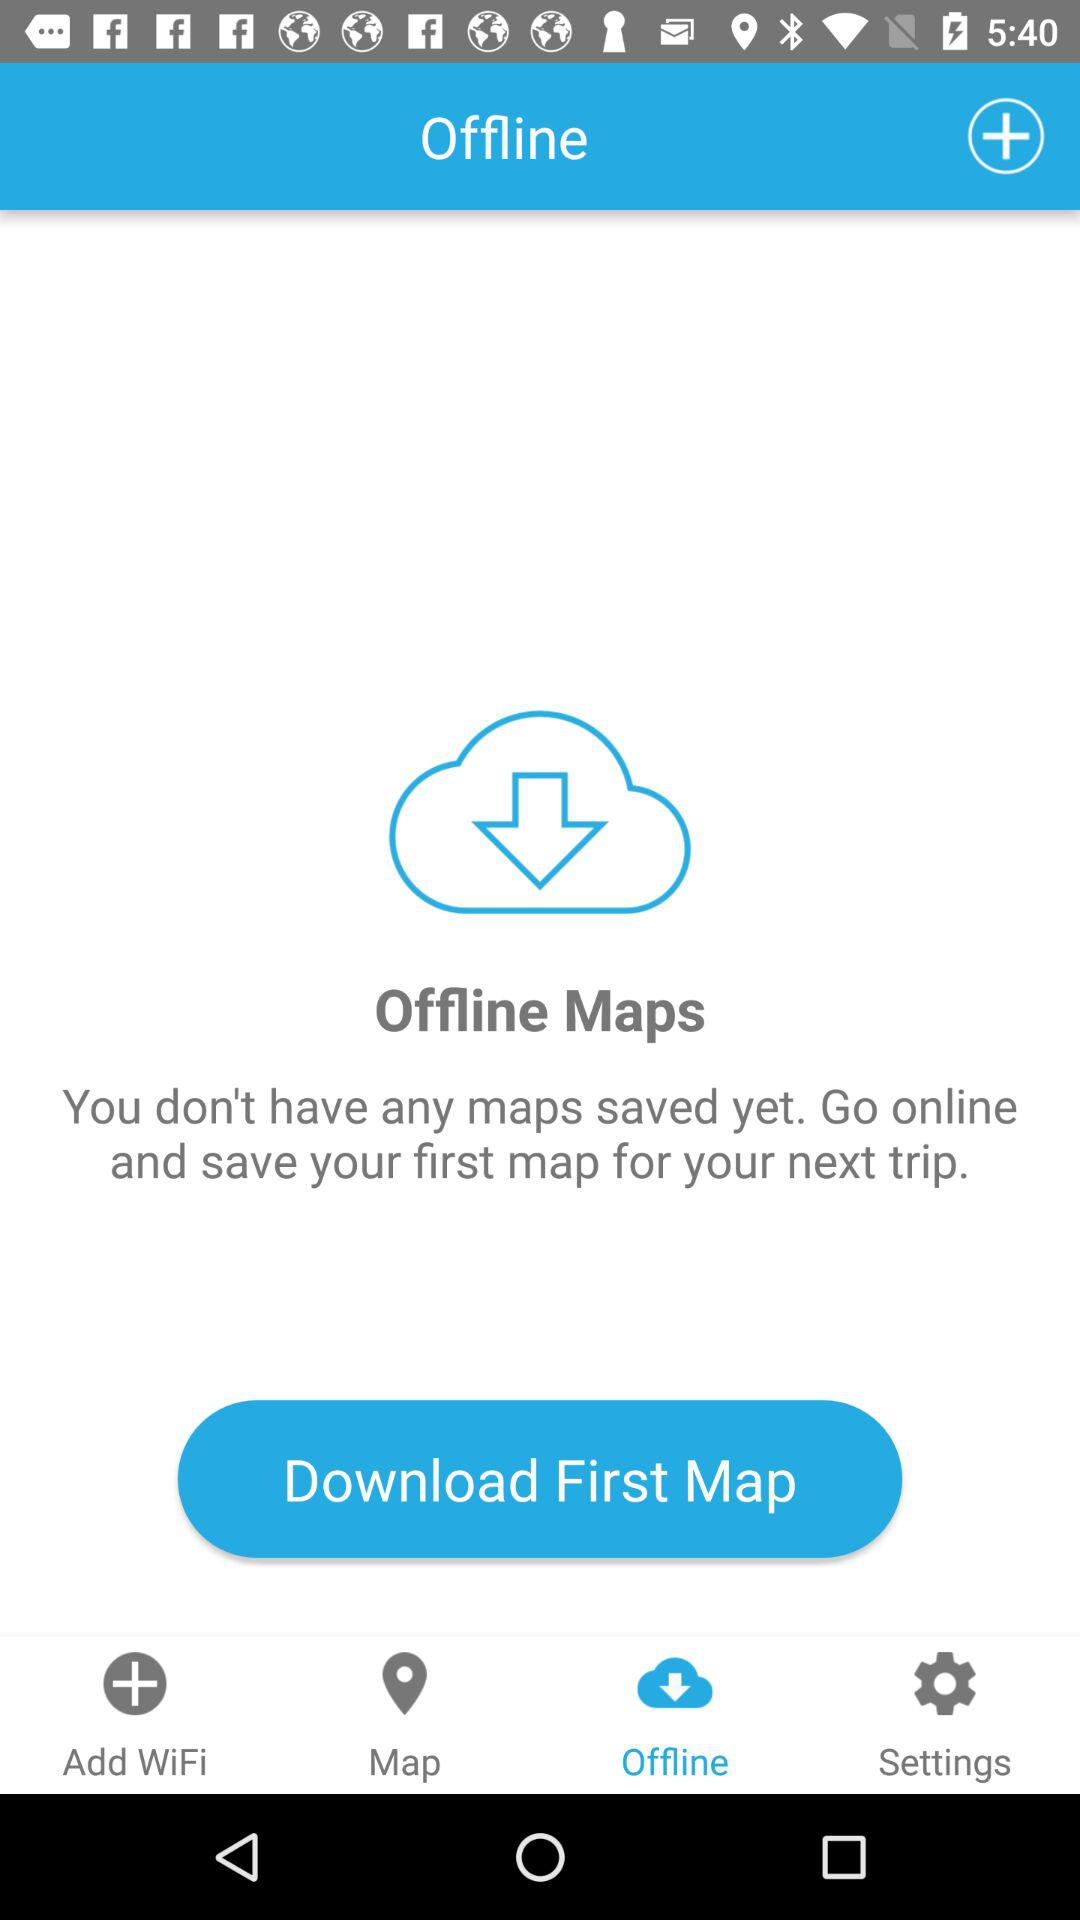How many maps are not saved offline?
Answer the question using a single word or phrase. 0 